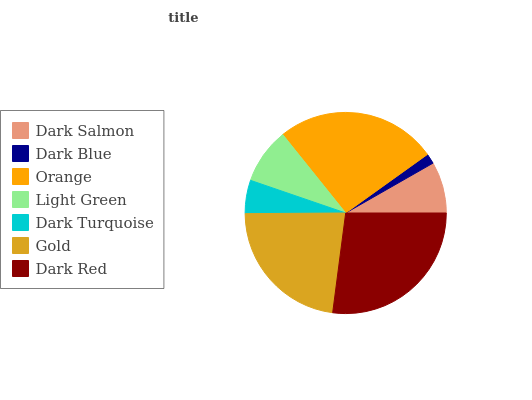Is Dark Blue the minimum?
Answer yes or no. Yes. Is Dark Red the maximum?
Answer yes or no. Yes. Is Orange the minimum?
Answer yes or no. No. Is Orange the maximum?
Answer yes or no. No. Is Orange greater than Dark Blue?
Answer yes or no. Yes. Is Dark Blue less than Orange?
Answer yes or no. Yes. Is Dark Blue greater than Orange?
Answer yes or no. No. Is Orange less than Dark Blue?
Answer yes or no. No. Is Light Green the high median?
Answer yes or no. Yes. Is Light Green the low median?
Answer yes or no. Yes. Is Dark Blue the high median?
Answer yes or no. No. Is Dark Blue the low median?
Answer yes or no. No. 